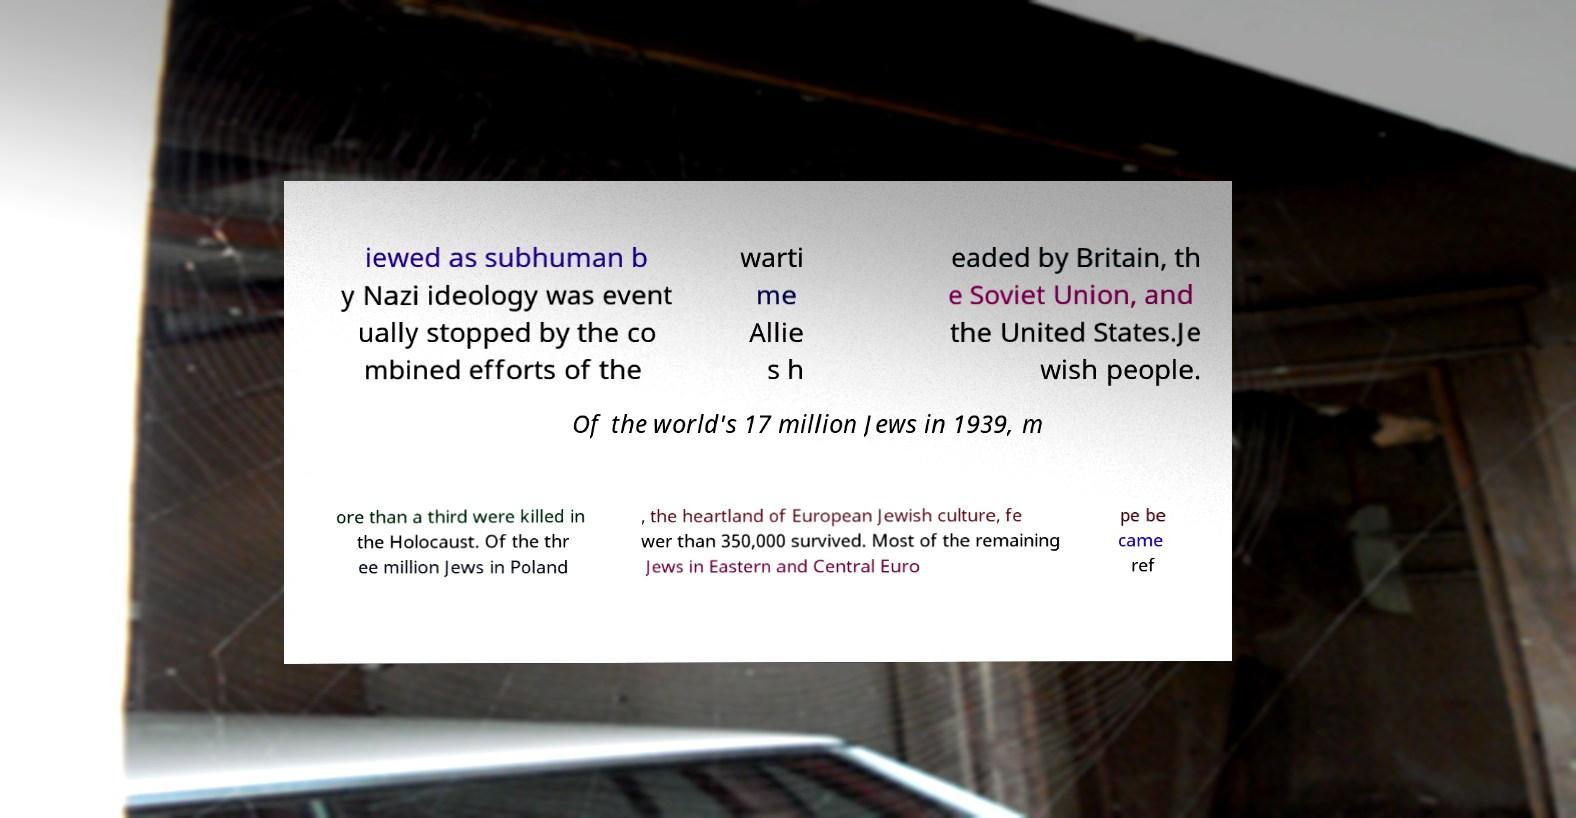Please identify and transcribe the text found in this image. iewed as subhuman b y Nazi ideology was event ually stopped by the co mbined efforts of the warti me Allie s h eaded by Britain, th e Soviet Union, and the United States.Je wish people. Of the world's 17 million Jews in 1939, m ore than a third were killed in the Holocaust. Of the thr ee million Jews in Poland , the heartland of European Jewish culture, fe wer than 350,000 survived. Most of the remaining Jews in Eastern and Central Euro pe be came ref 